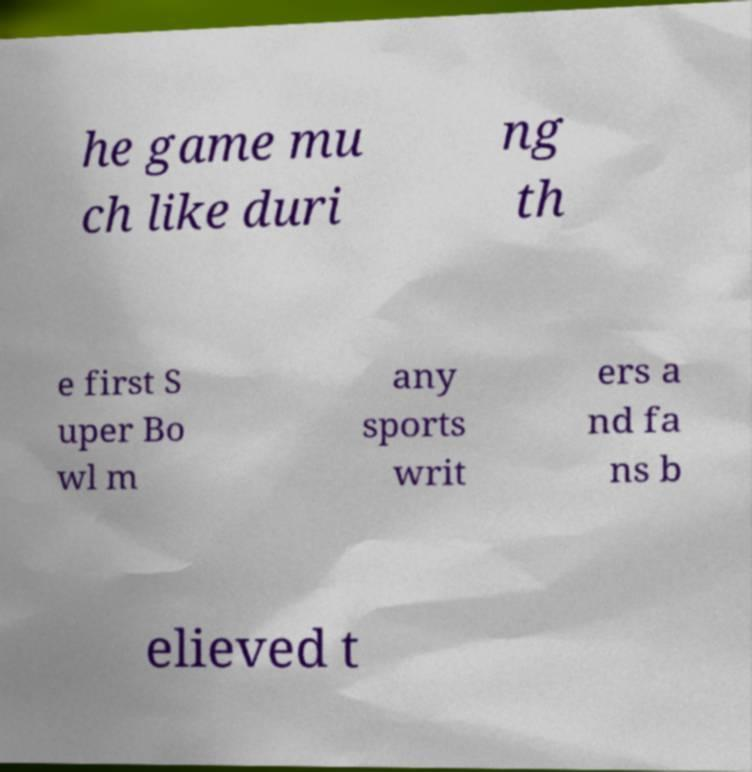For documentation purposes, I need the text within this image transcribed. Could you provide that? he game mu ch like duri ng th e first S uper Bo wl m any sports writ ers a nd fa ns b elieved t 